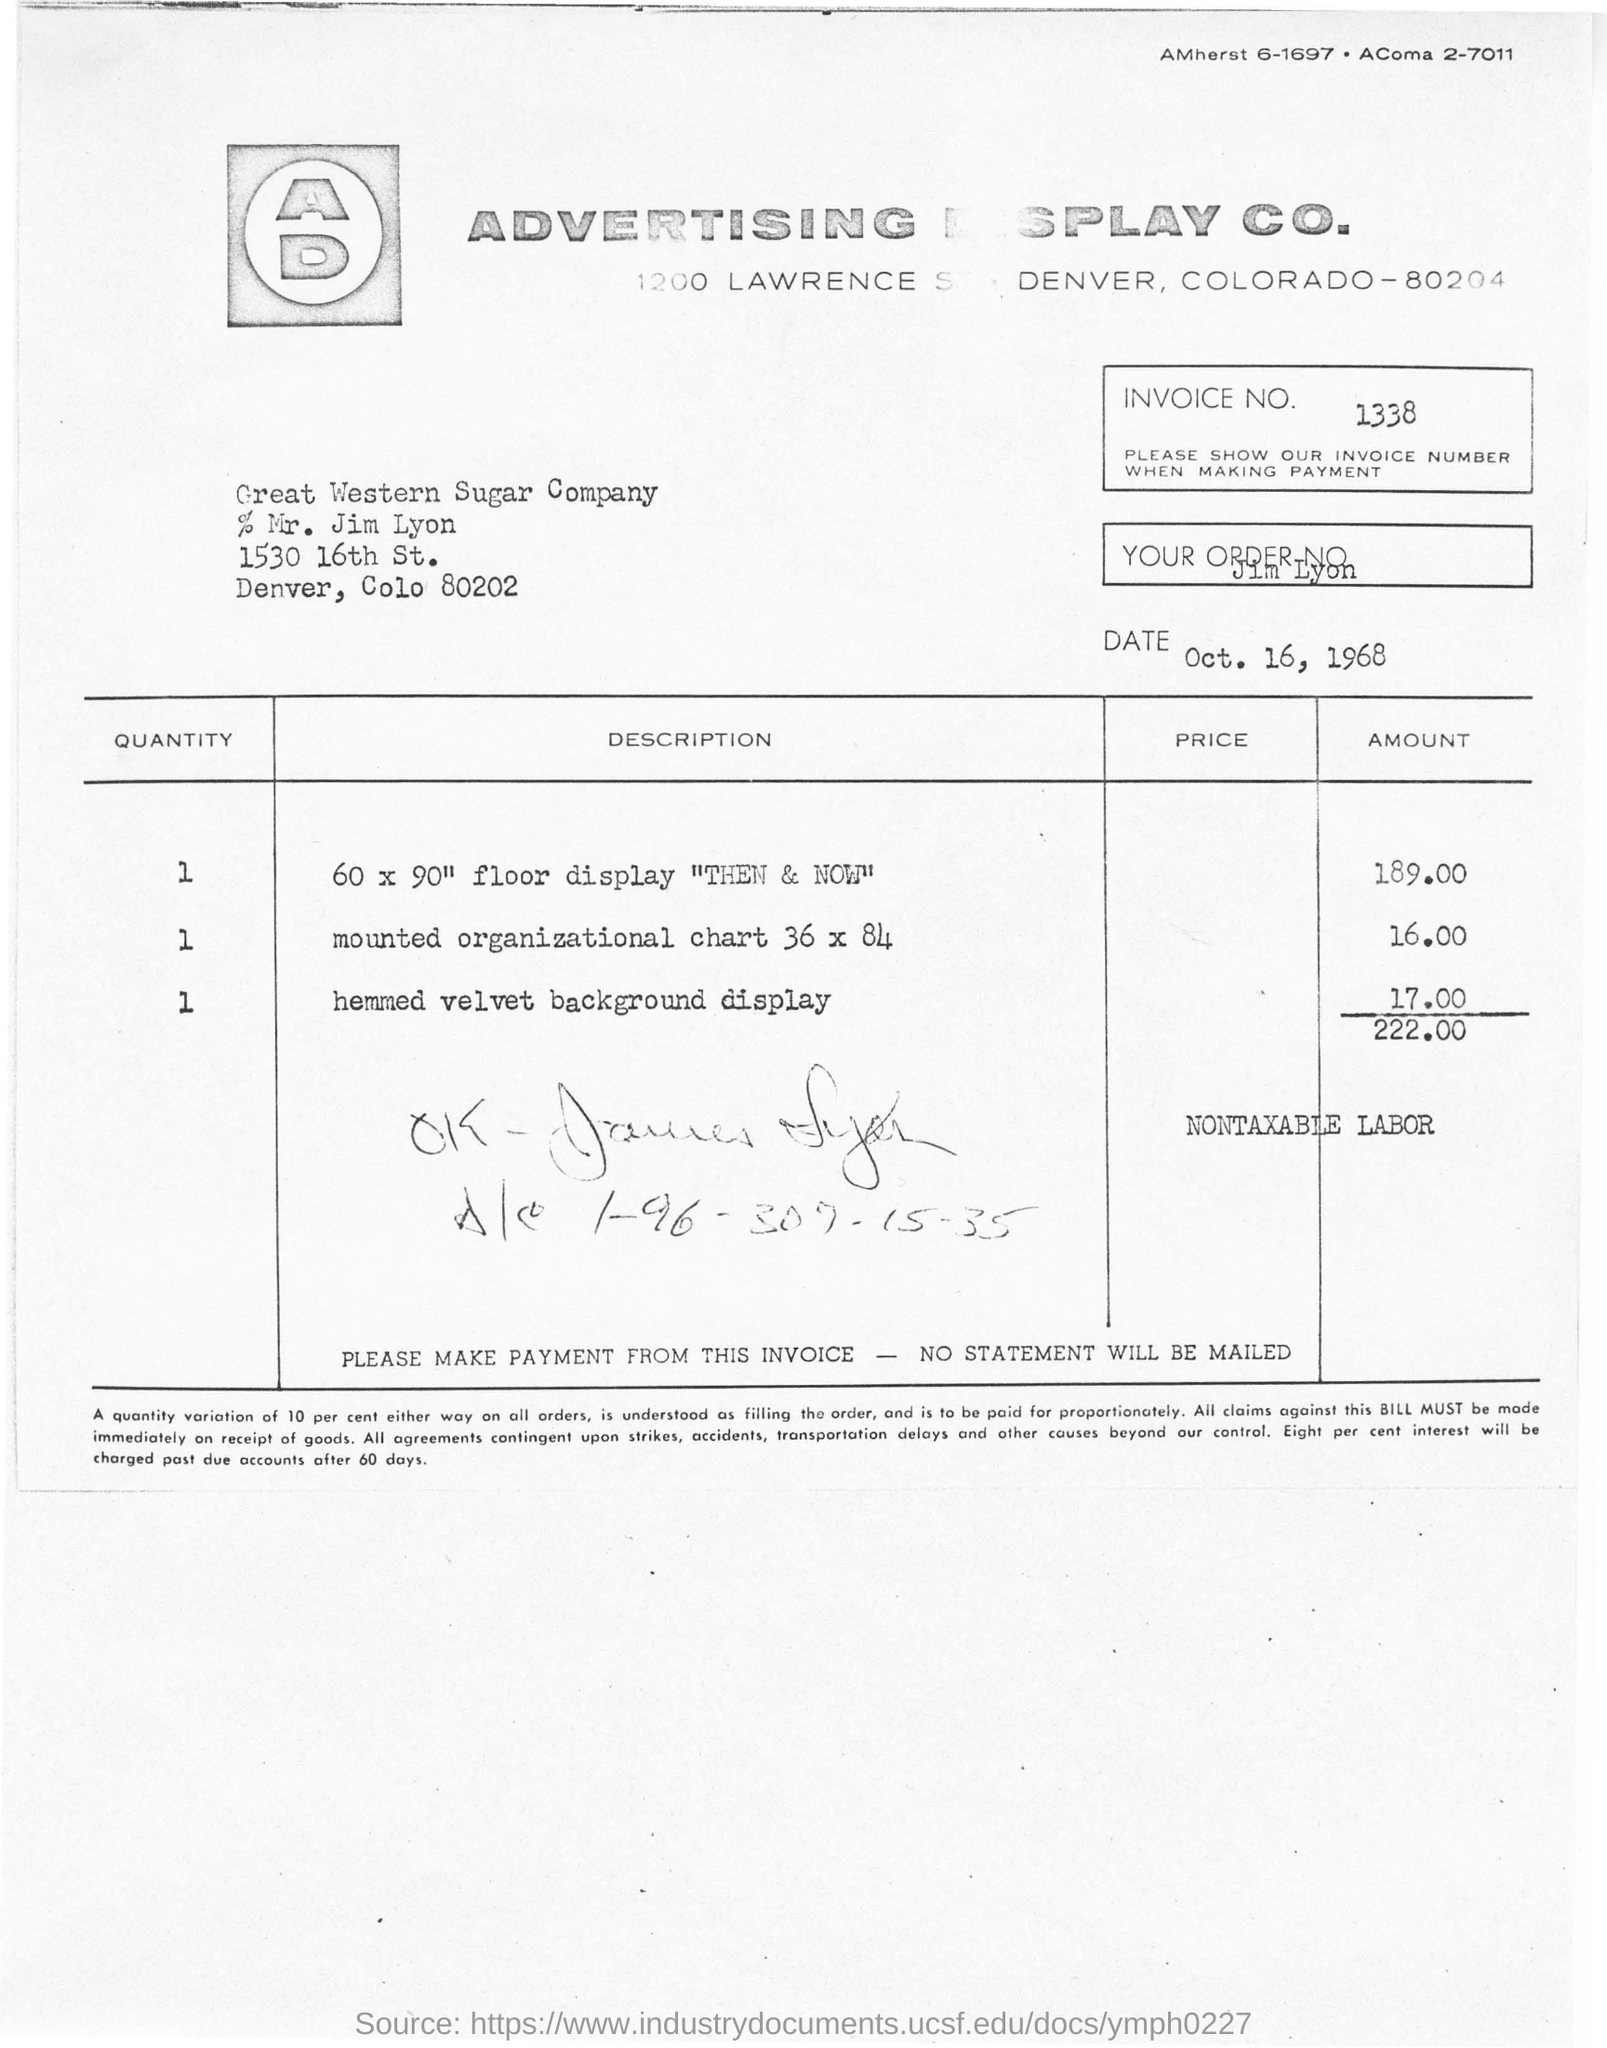Indicate a few pertinent items in this graphic. The invoice was issued on October 16, 1968. The invoice number for this invoice is 1338. The total amount in the invoice is 222,000. 